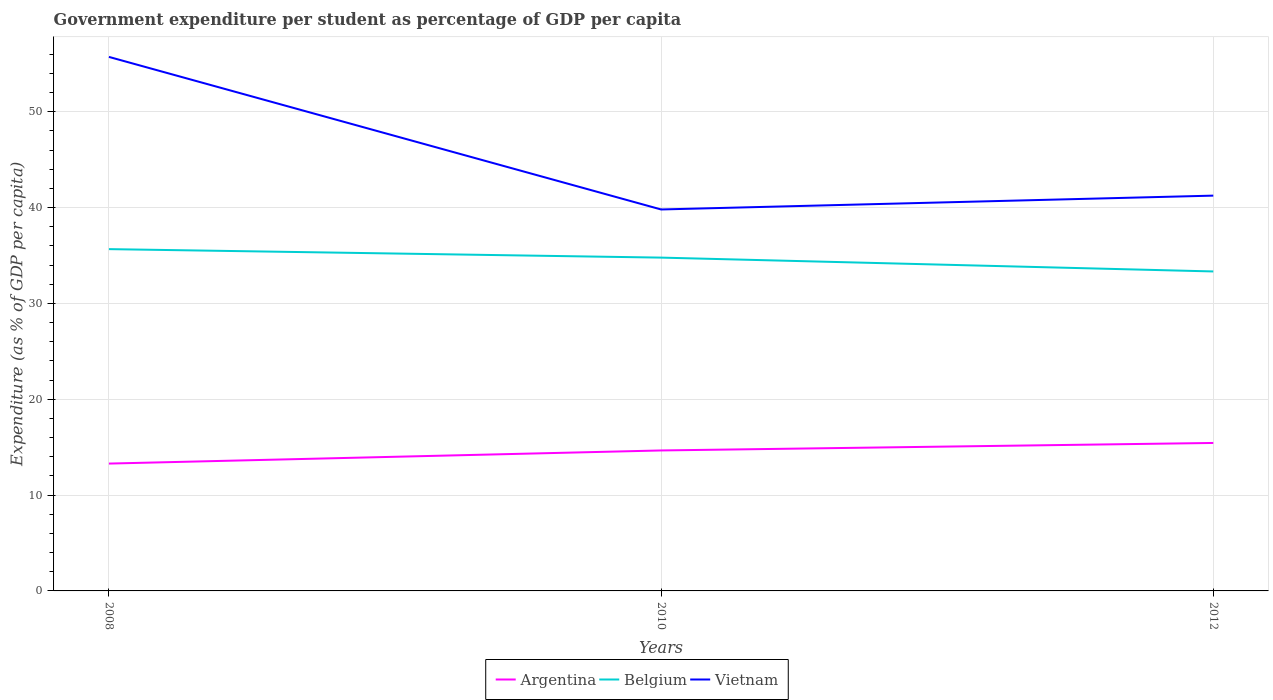How many different coloured lines are there?
Keep it short and to the point. 3. Does the line corresponding to Belgium intersect with the line corresponding to Vietnam?
Make the answer very short. No. Is the number of lines equal to the number of legend labels?
Make the answer very short. Yes. Across all years, what is the maximum percentage of expenditure per student in Argentina?
Keep it short and to the point. 13.29. What is the total percentage of expenditure per student in Argentina in the graph?
Your answer should be very brief. -1.37. What is the difference between the highest and the second highest percentage of expenditure per student in Belgium?
Your response must be concise. 2.33. How many lines are there?
Offer a terse response. 3. How many years are there in the graph?
Your answer should be compact. 3. Are the values on the major ticks of Y-axis written in scientific E-notation?
Ensure brevity in your answer.  No. Where does the legend appear in the graph?
Your response must be concise. Bottom center. What is the title of the graph?
Your answer should be very brief. Government expenditure per student as percentage of GDP per capita. Does "San Marino" appear as one of the legend labels in the graph?
Provide a succinct answer. No. What is the label or title of the Y-axis?
Give a very brief answer. Expenditure (as % of GDP per capita). What is the Expenditure (as % of GDP per capita) of Argentina in 2008?
Give a very brief answer. 13.29. What is the Expenditure (as % of GDP per capita) of Belgium in 2008?
Ensure brevity in your answer.  35.66. What is the Expenditure (as % of GDP per capita) in Vietnam in 2008?
Offer a very short reply. 55.71. What is the Expenditure (as % of GDP per capita) in Argentina in 2010?
Offer a terse response. 14.65. What is the Expenditure (as % of GDP per capita) of Belgium in 2010?
Your response must be concise. 34.77. What is the Expenditure (as % of GDP per capita) of Vietnam in 2010?
Your answer should be compact. 39.8. What is the Expenditure (as % of GDP per capita) in Argentina in 2012?
Offer a terse response. 15.44. What is the Expenditure (as % of GDP per capita) of Belgium in 2012?
Keep it short and to the point. 33.33. What is the Expenditure (as % of GDP per capita) in Vietnam in 2012?
Keep it short and to the point. 41.24. Across all years, what is the maximum Expenditure (as % of GDP per capita) in Argentina?
Your response must be concise. 15.44. Across all years, what is the maximum Expenditure (as % of GDP per capita) in Belgium?
Keep it short and to the point. 35.66. Across all years, what is the maximum Expenditure (as % of GDP per capita) of Vietnam?
Offer a terse response. 55.71. Across all years, what is the minimum Expenditure (as % of GDP per capita) of Argentina?
Your answer should be compact. 13.29. Across all years, what is the minimum Expenditure (as % of GDP per capita) in Belgium?
Make the answer very short. 33.33. Across all years, what is the minimum Expenditure (as % of GDP per capita) of Vietnam?
Provide a short and direct response. 39.8. What is the total Expenditure (as % of GDP per capita) in Argentina in the graph?
Make the answer very short. 43.38. What is the total Expenditure (as % of GDP per capita) in Belgium in the graph?
Ensure brevity in your answer.  103.76. What is the total Expenditure (as % of GDP per capita) in Vietnam in the graph?
Keep it short and to the point. 136.75. What is the difference between the Expenditure (as % of GDP per capita) of Argentina in 2008 and that in 2010?
Make the answer very short. -1.37. What is the difference between the Expenditure (as % of GDP per capita) of Belgium in 2008 and that in 2010?
Offer a very short reply. 0.88. What is the difference between the Expenditure (as % of GDP per capita) of Vietnam in 2008 and that in 2010?
Your response must be concise. 15.92. What is the difference between the Expenditure (as % of GDP per capita) of Argentina in 2008 and that in 2012?
Offer a very short reply. -2.15. What is the difference between the Expenditure (as % of GDP per capita) in Belgium in 2008 and that in 2012?
Make the answer very short. 2.33. What is the difference between the Expenditure (as % of GDP per capita) of Vietnam in 2008 and that in 2012?
Give a very brief answer. 14.47. What is the difference between the Expenditure (as % of GDP per capita) of Argentina in 2010 and that in 2012?
Your response must be concise. -0.78. What is the difference between the Expenditure (as % of GDP per capita) in Belgium in 2010 and that in 2012?
Keep it short and to the point. 1.45. What is the difference between the Expenditure (as % of GDP per capita) of Vietnam in 2010 and that in 2012?
Offer a terse response. -1.44. What is the difference between the Expenditure (as % of GDP per capita) in Argentina in 2008 and the Expenditure (as % of GDP per capita) in Belgium in 2010?
Offer a terse response. -21.49. What is the difference between the Expenditure (as % of GDP per capita) of Argentina in 2008 and the Expenditure (as % of GDP per capita) of Vietnam in 2010?
Offer a terse response. -26.51. What is the difference between the Expenditure (as % of GDP per capita) of Belgium in 2008 and the Expenditure (as % of GDP per capita) of Vietnam in 2010?
Give a very brief answer. -4.14. What is the difference between the Expenditure (as % of GDP per capita) of Argentina in 2008 and the Expenditure (as % of GDP per capita) of Belgium in 2012?
Give a very brief answer. -20.04. What is the difference between the Expenditure (as % of GDP per capita) of Argentina in 2008 and the Expenditure (as % of GDP per capita) of Vietnam in 2012?
Keep it short and to the point. -27.96. What is the difference between the Expenditure (as % of GDP per capita) in Belgium in 2008 and the Expenditure (as % of GDP per capita) in Vietnam in 2012?
Your response must be concise. -5.58. What is the difference between the Expenditure (as % of GDP per capita) of Argentina in 2010 and the Expenditure (as % of GDP per capita) of Belgium in 2012?
Give a very brief answer. -18.67. What is the difference between the Expenditure (as % of GDP per capita) in Argentina in 2010 and the Expenditure (as % of GDP per capita) in Vietnam in 2012?
Keep it short and to the point. -26.59. What is the difference between the Expenditure (as % of GDP per capita) in Belgium in 2010 and the Expenditure (as % of GDP per capita) in Vietnam in 2012?
Ensure brevity in your answer.  -6.47. What is the average Expenditure (as % of GDP per capita) in Argentina per year?
Your response must be concise. 14.46. What is the average Expenditure (as % of GDP per capita) of Belgium per year?
Your answer should be very brief. 34.59. What is the average Expenditure (as % of GDP per capita) of Vietnam per year?
Offer a very short reply. 45.58. In the year 2008, what is the difference between the Expenditure (as % of GDP per capita) in Argentina and Expenditure (as % of GDP per capita) in Belgium?
Your response must be concise. -22.37. In the year 2008, what is the difference between the Expenditure (as % of GDP per capita) in Argentina and Expenditure (as % of GDP per capita) in Vietnam?
Give a very brief answer. -42.43. In the year 2008, what is the difference between the Expenditure (as % of GDP per capita) in Belgium and Expenditure (as % of GDP per capita) in Vietnam?
Your answer should be very brief. -20.05. In the year 2010, what is the difference between the Expenditure (as % of GDP per capita) in Argentina and Expenditure (as % of GDP per capita) in Belgium?
Keep it short and to the point. -20.12. In the year 2010, what is the difference between the Expenditure (as % of GDP per capita) in Argentina and Expenditure (as % of GDP per capita) in Vietnam?
Offer a very short reply. -25.14. In the year 2010, what is the difference between the Expenditure (as % of GDP per capita) in Belgium and Expenditure (as % of GDP per capita) in Vietnam?
Give a very brief answer. -5.02. In the year 2012, what is the difference between the Expenditure (as % of GDP per capita) in Argentina and Expenditure (as % of GDP per capita) in Belgium?
Your response must be concise. -17.89. In the year 2012, what is the difference between the Expenditure (as % of GDP per capita) of Argentina and Expenditure (as % of GDP per capita) of Vietnam?
Your response must be concise. -25.8. In the year 2012, what is the difference between the Expenditure (as % of GDP per capita) in Belgium and Expenditure (as % of GDP per capita) in Vietnam?
Make the answer very short. -7.91. What is the ratio of the Expenditure (as % of GDP per capita) in Argentina in 2008 to that in 2010?
Offer a very short reply. 0.91. What is the ratio of the Expenditure (as % of GDP per capita) in Belgium in 2008 to that in 2010?
Make the answer very short. 1.03. What is the ratio of the Expenditure (as % of GDP per capita) in Vietnam in 2008 to that in 2010?
Make the answer very short. 1.4. What is the ratio of the Expenditure (as % of GDP per capita) in Argentina in 2008 to that in 2012?
Give a very brief answer. 0.86. What is the ratio of the Expenditure (as % of GDP per capita) in Belgium in 2008 to that in 2012?
Provide a succinct answer. 1.07. What is the ratio of the Expenditure (as % of GDP per capita) in Vietnam in 2008 to that in 2012?
Give a very brief answer. 1.35. What is the ratio of the Expenditure (as % of GDP per capita) of Argentina in 2010 to that in 2012?
Your response must be concise. 0.95. What is the ratio of the Expenditure (as % of GDP per capita) in Belgium in 2010 to that in 2012?
Provide a short and direct response. 1.04. What is the difference between the highest and the second highest Expenditure (as % of GDP per capita) in Argentina?
Your answer should be compact. 0.78. What is the difference between the highest and the second highest Expenditure (as % of GDP per capita) of Belgium?
Keep it short and to the point. 0.88. What is the difference between the highest and the second highest Expenditure (as % of GDP per capita) of Vietnam?
Your response must be concise. 14.47. What is the difference between the highest and the lowest Expenditure (as % of GDP per capita) in Argentina?
Provide a succinct answer. 2.15. What is the difference between the highest and the lowest Expenditure (as % of GDP per capita) of Belgium?
Your answer should be compact. 2.33. What is the difference between the highest and the lowest Expenditure (as % of GDP per capita) of Vietnam?
Keep it short and to the point. 15.92. 